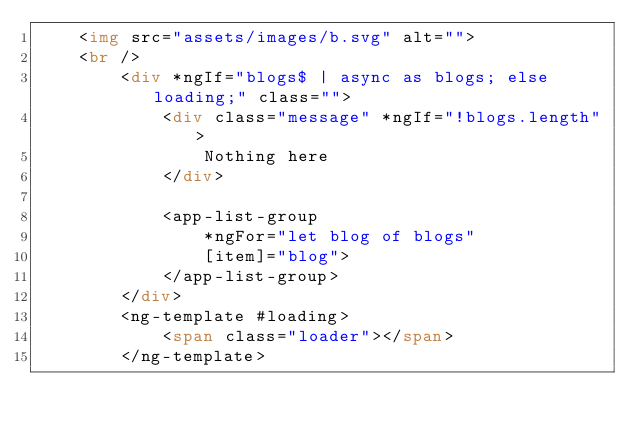<code> <loc_0><loc_0><loc_500><loc_500><_HTML_>    <img src="assets/images/b.svg" alt="">
    <br />
        <div *ngIf="blogs$ | async as blogs; else loading;" class="">
            <div class="message" *ngIf="!blogs.length">
                Nothing here
            </div>

            <app-list-group
                *ngFor="let blog of blogs"
                [item]="blog">
            </app-list-group>
        </div>
        <ng-template #loading>
            <span class="loader"></span>
        </ng-template>

</code> 